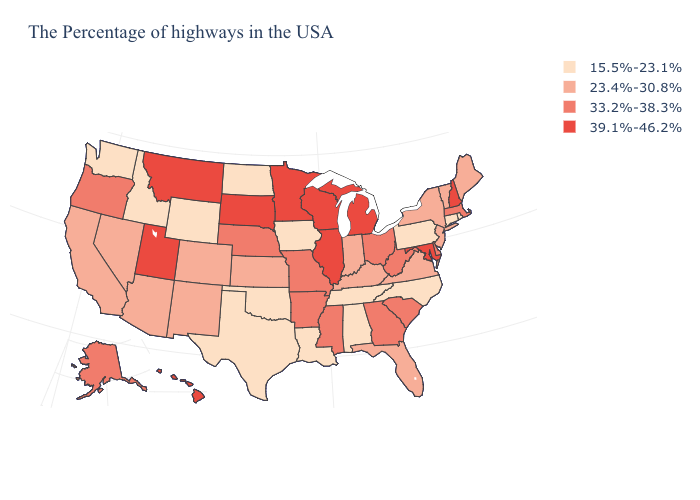What is the lowest value in states that border New Jersey?
Be succinct. 15.5%-23.1%. Name the states that have a value in the range 39.1%-46.2%?
Concise answer only. New Hampshire, Maryland, Michigan, Wisconsin, Illinois, Minnesota, South Dakota, Utah, Montana, Hawaii. Name the states that have a value in the range 39.1%-46.2%?
Short answer required. New Hampshire, Maryland, Michigan, Wisconsin, Illinois, Minnesota, South Dakota, Utah, Montana, Hawaii. What is the value of Oregon?
Be succinct. 33.2%-38.3%. Name the states that have a value in the range 23.4%-30.8%?
Answer briefly. Maine, Vermont, New York, New Jersey, Virginia, Florida, Kentucky, Indiana, Kansas, Colorado, New Mexico, Arizona, Nevada, California. What is the lowest value in the South?
Give a very brief answer. 15.5%-23.1%. What is the value of Kansas?
Keep it brief. 23.4%-30.8%. Name the states that have a value in the range 33.2%-38.3%?
Concise answer only. Massachusetts, Delaware, South Carolina, West Virginia, Ohio, Georgia, Mississippi, Missouri, Arkansas, Nebraska, Oregon, Alaska. Among the states that border Kansas , does Nebraska have the lowest value?
Short answer required. No. Name the states that have a value in the range 15.5%-23.1%?
Be succinct. Rhode Island, Connecticut, Pennsylvania, North Carolina, Alabama, Tennessee, Louisiana, Iowa, Oklahoma, Texas, North Dakota, Wyoming, Idaho, Washington. What is the value of Alabama?
Concise answer only. 15.5%-23.1%. What is the value of Rhode Island?
Write a very short answer. 15.5%-23.1%. What is the value of West Virginia?
Quick response, please. 33.2%-38.3%. How many symbols are there in the legend?
Keep it brief. 4. What is the value of Tennessee?
Keep it brief. 15.5%-23.1%. 